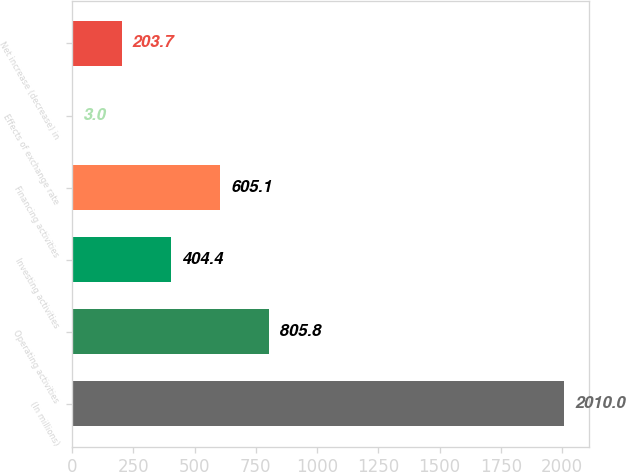<chart> <loc_0><loc_0><loc_500><loc_500><bar_chart><fcel>(In millions)<fcel>Operating activities<fcel>Investing activities<fcel>Financing activities<fcel>Effects of exchange rate<fcel>Net increase (decrease) in<nl><fcel>2010<fcel>805.8<fcel>404.4<fcel>605.1<fcel>3<fcel>203.7<nl></chart> 